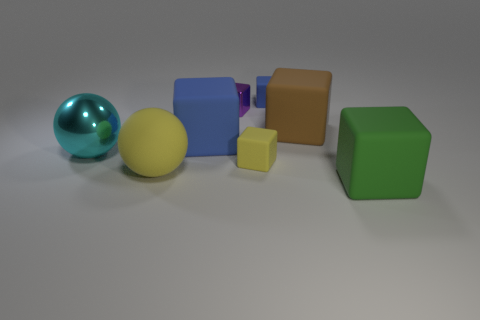Subtract all yellow rubber cubes. How many cubes are left? 5 Subtract all blue cubes. How many cubes are left? 4 Subtract all yellow balls. Subtract all purple cubes. How many balls are left? 1 Add 1 cyan shiny objects. How many objects exist? 9 Subtract all blocks. How many objects are left? 2 Subtract 0 cyan cylinders. How many objects are left? 8 Subtract all tiny blue rubber objects. Subtract all yellow rubber blocks. How many objects are left? 6 Add 4 yellow matte things. How many yellow matte things are left? 6 Add 7 small green balls. How many small green balls exist? 7 